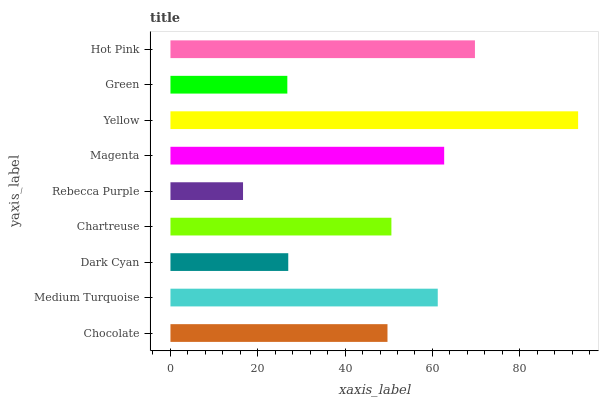Is Rebecca Purple the minimum?
Answer yes or no. Yes. Is Yellow the maximum?
Answer yes or no. Yes. Is Medium Turquoise the minimum?
Answer yes or no. No. Is Medium Turquoise the maximum?
Answer yes or no. No. Is Medium Turquoise greater than Chocolate?
Answer yes or no. Yes. Is Chocolate less than Medium Turquoise?
Answer yes or no. Yes. Is Chocolate greater than Medium Turquoise?
Answer yes or no. No. Is Medium Turquoise less than Chocolate?
Answer yes or no. No. Is Chartreuse the high median?
Answer yes or no. Yes. Is Chartreuse the low median?
Answer yes or no. Yes. Is Medium Turquoise the high median?
Answer yes or no. No. Is Hot Pink the low median?
Answer yes or no. No. 